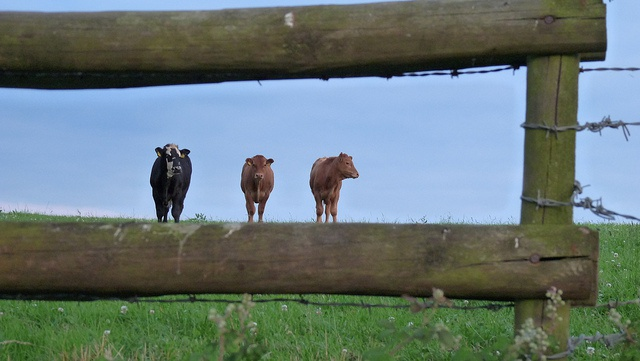Describe the objects in this image and their specific colors. I can see cow in lightblue, black, and gray tones, cow in lightblue, maroon, brown, black, and gray tones, and cow in lightblue, maroon, brown, black, and gray tones in this image. 